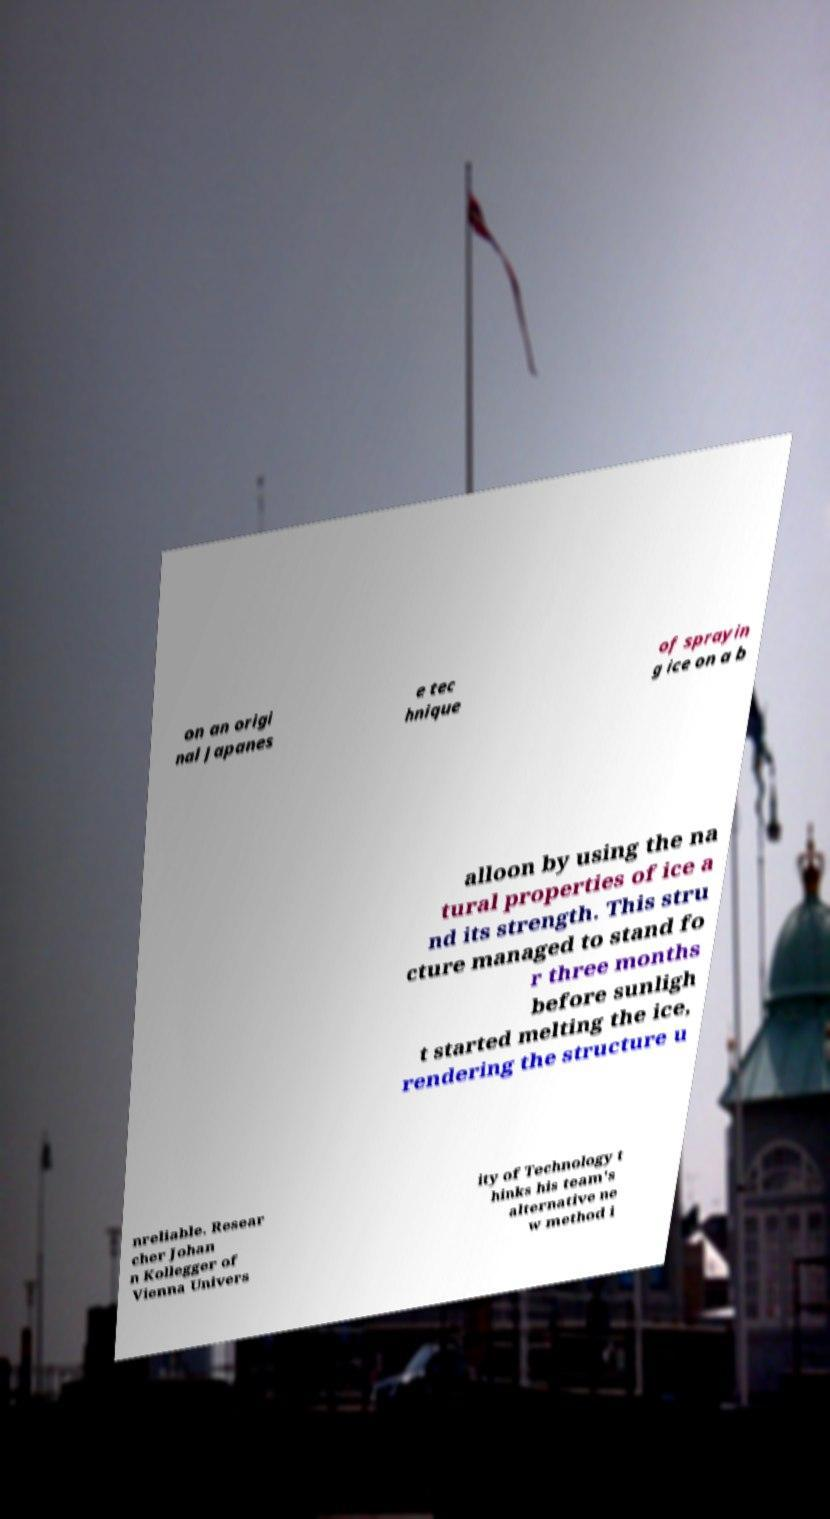There's text embedded in this image that I need extracted. Can you transcribe it verbatim? on an origi nal Japanes e tec hnique of sprayin g ice on a b alloon by using the na tural properties of ice a nd its strength. This stru cture managed to stand fo r three months before sunligh t started melting the ice, rendering the structure u nreliable. Resear cher Johan n Kollegger of Vienna Univers ity of Technology t hinks his team's alternative ne w method i 